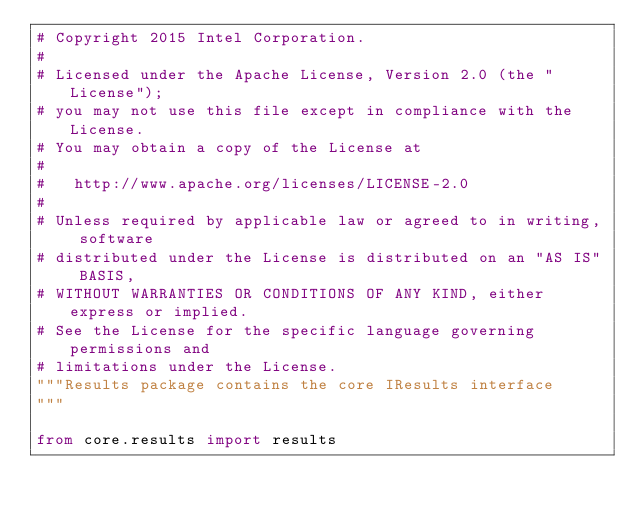<code> <loc_0><loc_0><loc_500><loc_500><_Python_># Copyright 2015 Intel Corporation.
#
# Licensed under the Apache License, Version 2.0 (the "License");
# you may not use this file except in compliance with the License.
# You may obtain a copy of the License at
#
#   http://www.apache.org/licenses/LICENSE-2.0
#
# Unless required by applicable law or agreed to in writing, software
# distributed under the License is distributed on an "AS IS" BASIS,
# WITHOUT WARRANTIES OR CONDITIONS OF ANY KIND, either express or implied.
# See the License for the specific language governing permissions and
# limitations under the License.
"""Results package contains the core IResults interface
"""

from core.results import results
</code> 